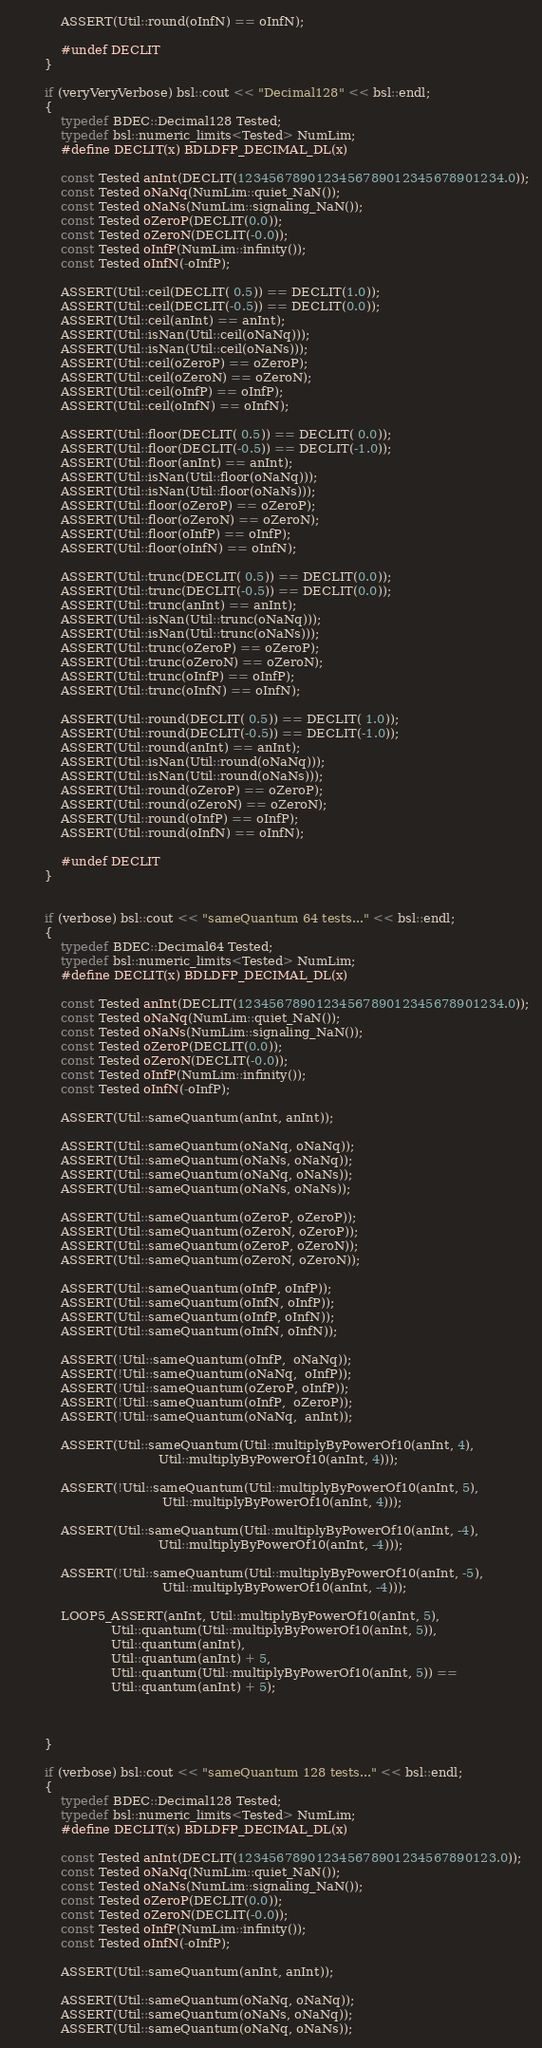Convert code to text. <code><loc_0><loc_0><loc_500><loc_500><_C++_>            ASSERT(Util::round(oInfN) == oInfN);

            #undef DECLIT
        }

        if (veryVeryVerbose) bsl::cout << "Decimal128" << bsl::endl;
        {
            typedef BDEC::Decimal128 Tested;
            typedef bsl::numeric_limits<Tested> NumLim;
            #define DECLIT(x) BDLDFP_DECIMAL_DL(x)

            const Tested anInt(DECLIT(1234567890123456789012345678901234.0));
            const Tested oNaNq(NumLim::quiet_NaN());
            const Tested oNaNs(NumLim::signaling_NaN());
            const Tested oZeroP(DECLIT(0.0));
            const Tested oZeroN(DECLIT(-0.0));
            const Tested oInfP(NumLim::infinity());
            const Tested oInfN(-oInfP);

            ASSERT(Util::ceil(DECLIT( 0.5)) == DECLIT(1.0));
            ASSERT(Util::ceil(DECLIT(-0.5)) == DECLIT(0.0));
            ASSERT(Util::ceil(anInt) == anInt);
            ASSERT(Util::isNan(Util::ceil(oNaNq)));
            ASSERT(Util::isNan(Util::ceil(oNaNs)));
            ASSERT(Util::ceil(oZeroP) == oZeroP);
            ASSERT(Util::ceil(oZeroN) == oZeroN);
            ASSERT(Util::ceil(oInfP) == oInfP);
            ASSERT(Util::ceil(oInfN) == oInfN);

            ASSERT(Util::floor(DECLIT( 0.5)) == DECLIT( 0.0));
            ASSERT(Util::floor(DECLIT(-0.5)) == DECLIT(-1.0));
            ASSERT(Util::floor(anInt) == anInt);
            ASSERT(Util::isNan(Util::floor(oNaNq)));
            ASSERT(Util::isNan(Util::floor(oNaNs)));
            ASSERT(Util::floor(oZeroP) == oZeroP);
            ASSERT(Util::floor(oZeroN) == oZeroN);
            ASSERT(Util::floor(oInfP) == oInfP);
            ASSERT(Util::floor(oInfN) == oInfN);

            ASSERT(Util::trunc(DECLIT( 0.5)) == DECLIT(0.0));
            ASSERT(Util::trunc(DECLIT(-0.5)) == DECLIT(0.0));
            ASSERT(Util::trunc(anInt) == anInt);
            ASSERT(Util::isNan(Util::trunc(oNaNq)));
            ASSERT(Util::isNan(Util::trunc(oNaNs)));
            ASSERT(Util::trunc(oZeroP) == oZeroP);
            ASSERT(Util::trunc(oZeroN) == oZeroN);
            ASSERT(Util::trunc(oInfP) == oInfP);
            ASSERT(Util::trunc(oInfN) == oInfN);

            ASSERT(Util::round(DECLIT( 0.5)) == DECLIT( 1.0));
            ASSERT(Util::round(DECLIT(-0.5)) == DECLIT(-1.0));
            ASSERT(Util::round(anInt) == anInt);
            ASSERT(Util::isNan(Util::round(oNaNq)));
            ASSERT(Util::isNan(Util::round(oNaNs)));
            ASSERT(Util::round(oZeroP) == oZeroP);
            ASSERT(Util::round(oZeroN) == oZeroN);
            ASSERT(Util::round(oInfP) == oInfP);
            ASSERT(Util::round(oInfN) == oInfN);

            #undef DECLIT
        }


        if (verbose) bsl::cout << "sameQuantum 64 tests..." << bsl::endl;
        {
            typedef BDEC::Decimal64 Tested;
            typedef bsl::numeric_limits<Tested> NumLim;
            #define DECLIT(x) BDLDFP_DECIMAL_DL(x)

            const Tested anInt(DECLIT(1234567890123456789012345678901234.0));
            const Tested oNaNq(NumLim::quiet_NaN());
            const Tested oNaNs(NumLim::signaling_NaN());
            const Tested oZeroP(DECLIT(0.0));
            const Tested oZeroN(DECLIT(-0.0));
            const Tested oInfP(NumLim::infinity());
            const Tested oInfN(-oInfP);

            ASSERT(Util::sameQuantum(anInt, anInt));

            ASSERT(Util::sameQuantum(oNaNq, oNaNq));
            ASSERT(Util::sameQuantum(oNaNs, oNaNq));
            ASSERT(Util::sameQuantum(oNaNq, oNaNs));
            ASSERT(Util::sameQuantum(oNaNs, oNaNs));

            ASSERT(Util::sameQuantum(oZeroP, oZeroP));
            ASSERT(Util::sameQuantum(oZeroN, oZeroP));
            ASSERT(Util::sameQuantum(oZeroP, oZeroN));
            ASSERT(Util::sameQuantum(oZeroN, oZeroN));

            ASSERT(Util::sameQuantum(oInfP, oInfP));
            ASSERT(Util::sameQuantum(oInfN, oInfP));
            ASSERT(Util::sameQuantum(oInfP, oInfN));
            ASSERT(Util::sameQuantum(oInfN, oInfN));

            ASSERT(!Util::sameQuantum(oInfP,  oNaNq));
            ASSERT(!Util::sameQuantum(oNaNq,  oInfP));
            ASSERT(!Util::sameQuantum(oZeroP, oInfP));
            ASSERT(!Util::sameQuantum(oInfP,  oZeroP));
            ASSERT(!Util::sameQuantum(oNaNq,  anInt));

            ASSERT(Util::sameQuantum(Util::multiplyByPowerOf10(anInt, 4),
                                     Util::multiplyByPowerOf10(anInt, 4)));

            ASSERT(!Util::sameQuantum(Util::multiplyByPowerOf10(anInt, 5),
                                      Util::multiplyByPowerOf10(anInt, 4)));

            ASSERT(Util::sameQuantum(Util::multiplyByPowerOf10(anInt, -4),
                                     Util::multiplyByPowerOf10(anInt, -4)));

            ASSERT(!Util::sameQuantum(Util::multiplyByPowerOf10(anInt, -5),
                                      Util::multiplyByPowerOf10(anInt, -4)));

            LOOP5_ASSERT(anInt, Util::multiplyByPowerOf10(anInt, 5),
                         Util::quantum(Util::multiplyByPowerOf10(anInt, 5)),
                         Util::quantum(anInt),
                         Util::quantum(anInt) + 5,
                         Util::quantum(Util::multiplyByPowerOf10(anInt, 5)) ==
                         Util::quantum(anInt) + 5);



        }

        if (verbose) bsl::cout << "sameQuantum 128 tests..." << bsl::endl;
        {
            typedef BDEC::Decimal128 Tested;
            typedef bsl::numeric_limits<Tested> NumLim;
            #define DECLIT(x) BDLDFP_DECIMAL_DL(x)

            const Tested anInt(DECLIT(123456789012345678901234567890123.0));
            const Tested oNaNq(NumLim::quiet_NaN());
            const Tested oNaNs(NumLim::signaling_NaN());
            const Tested oZeroP(DECLIT(0.0));
            const Tested oZeroN(DECLIT(-0.0));
            const Tested oInfP(NumLim::infinity());
            const Tested oInfN(-oInfP);

            ASSERT(Util::sameQuantum(anInt, anInt));

            ASSERT(Util::sameQuantum(oNaNq, oNaNq));
            ASSERT(Util::sameQuantum(oNaNs, oNaNq));
            ASSERT(Util::sameQuantum(oNaNq, oNaNs));</code> 